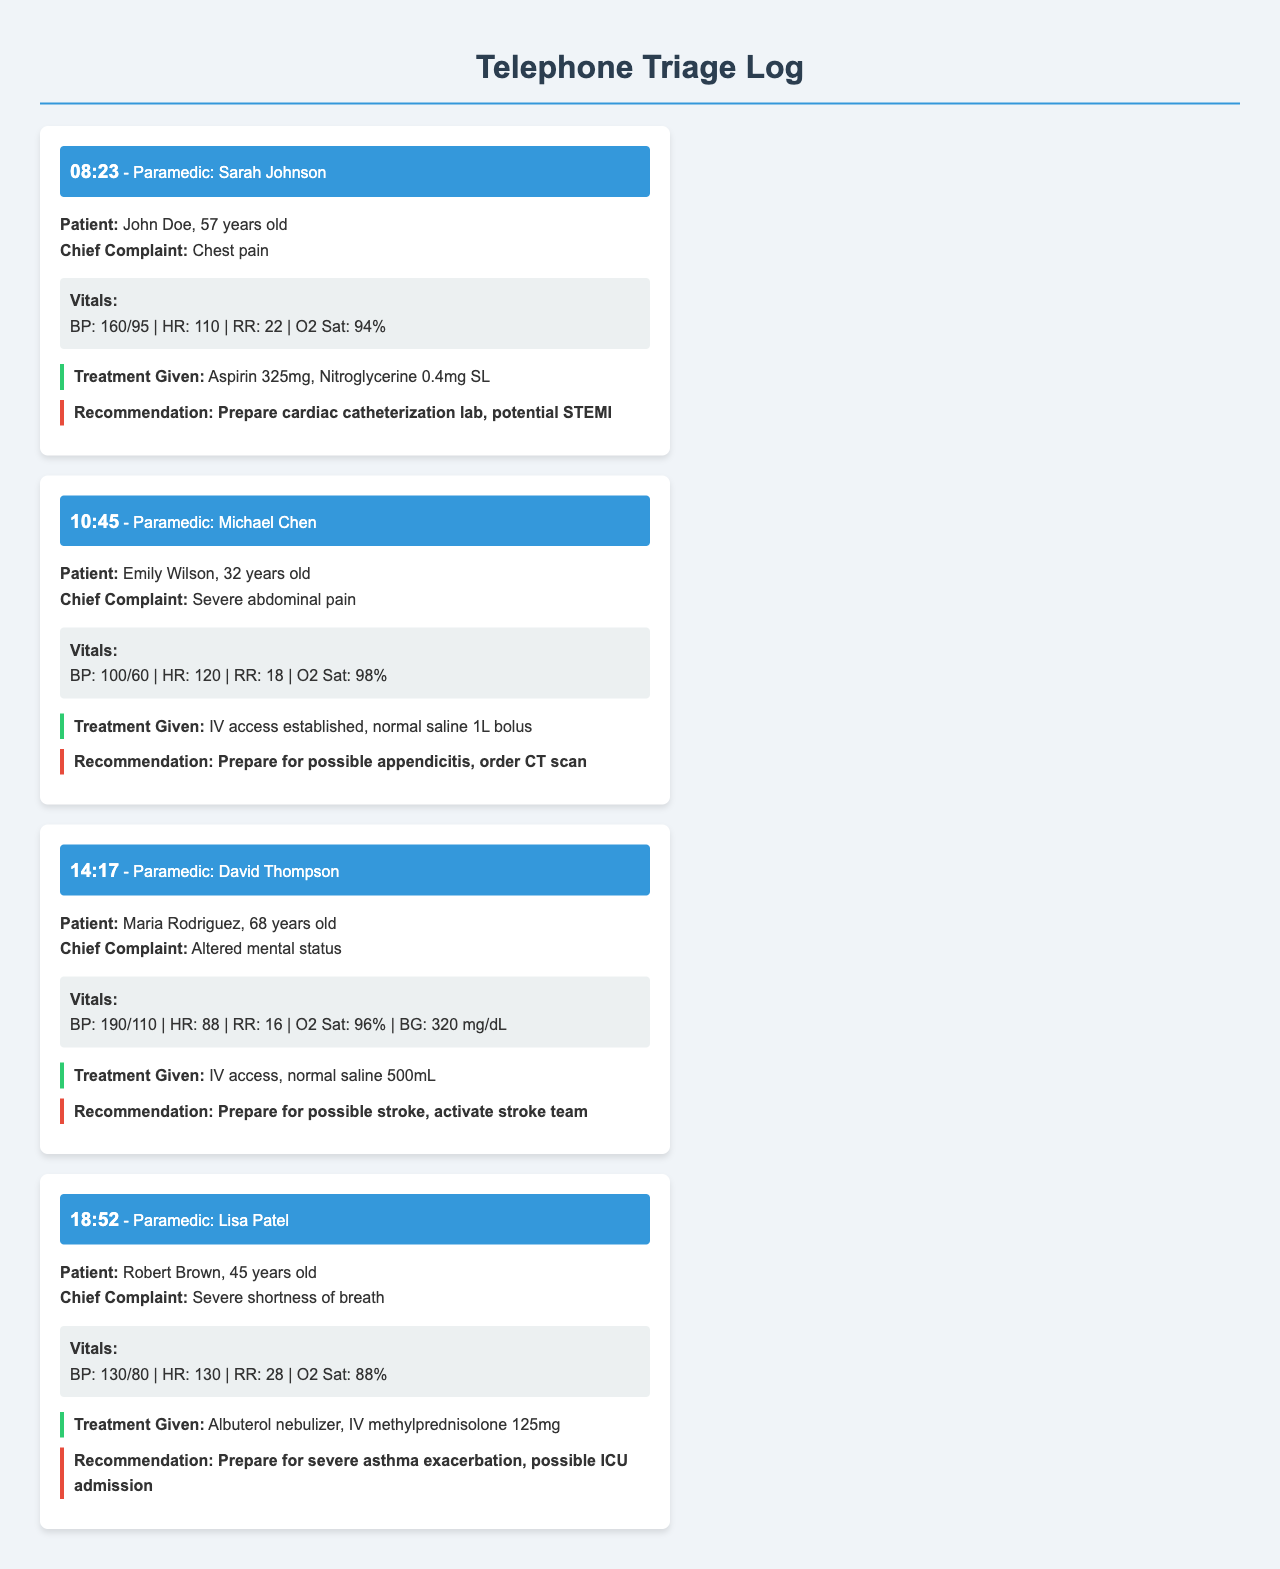what time did Sarah Johnson make her call? The call made by Sarah Johnson is logged at 08:23.
Answer: 08:23 what is the chief complaint of John Doe? The chief complaint for John Doe is chest pain.
Answer: chest pain how old is Emily Wilson? The document states that Emily Wilson is 32 years old.
Answer: 32 years old what treatment was given to Robert Brown? The treatment given to Robert Brown includes Albuterol nebulizer and IV methylprednisolone 125mg.
Answer: Albuterol nebulizer, IV methylprednisolone 125mg what vital sign indicates a high blood pressure for Maria Rodriguez? The blood pressure for Maria Rodriguez is recorded as 190/110, indicating hypertension.
Answer: 190/110 what is the recommendation for Maria Rodriguez? The recommendation for Maria Rodriguez is to prepare for possible stroke and activate the stroke team.
Answer: Prepare for possible stroke, activate stroke team which paramedic reported a patient with altered mental status? David Thompson is the paramedic who reported the patient with altered mental status.
Answer: David Thompson what was the heart rate for Robert Brown? Robert Brown's heart rate is noted as 130.
Answer: 130 what is the vital sign that indicates a risk of hypoxia for Robert Brown? The oxygen saturation for Robert Brown is noted as 88%, indicating a risk of hypoxia.
Answer: 88% 